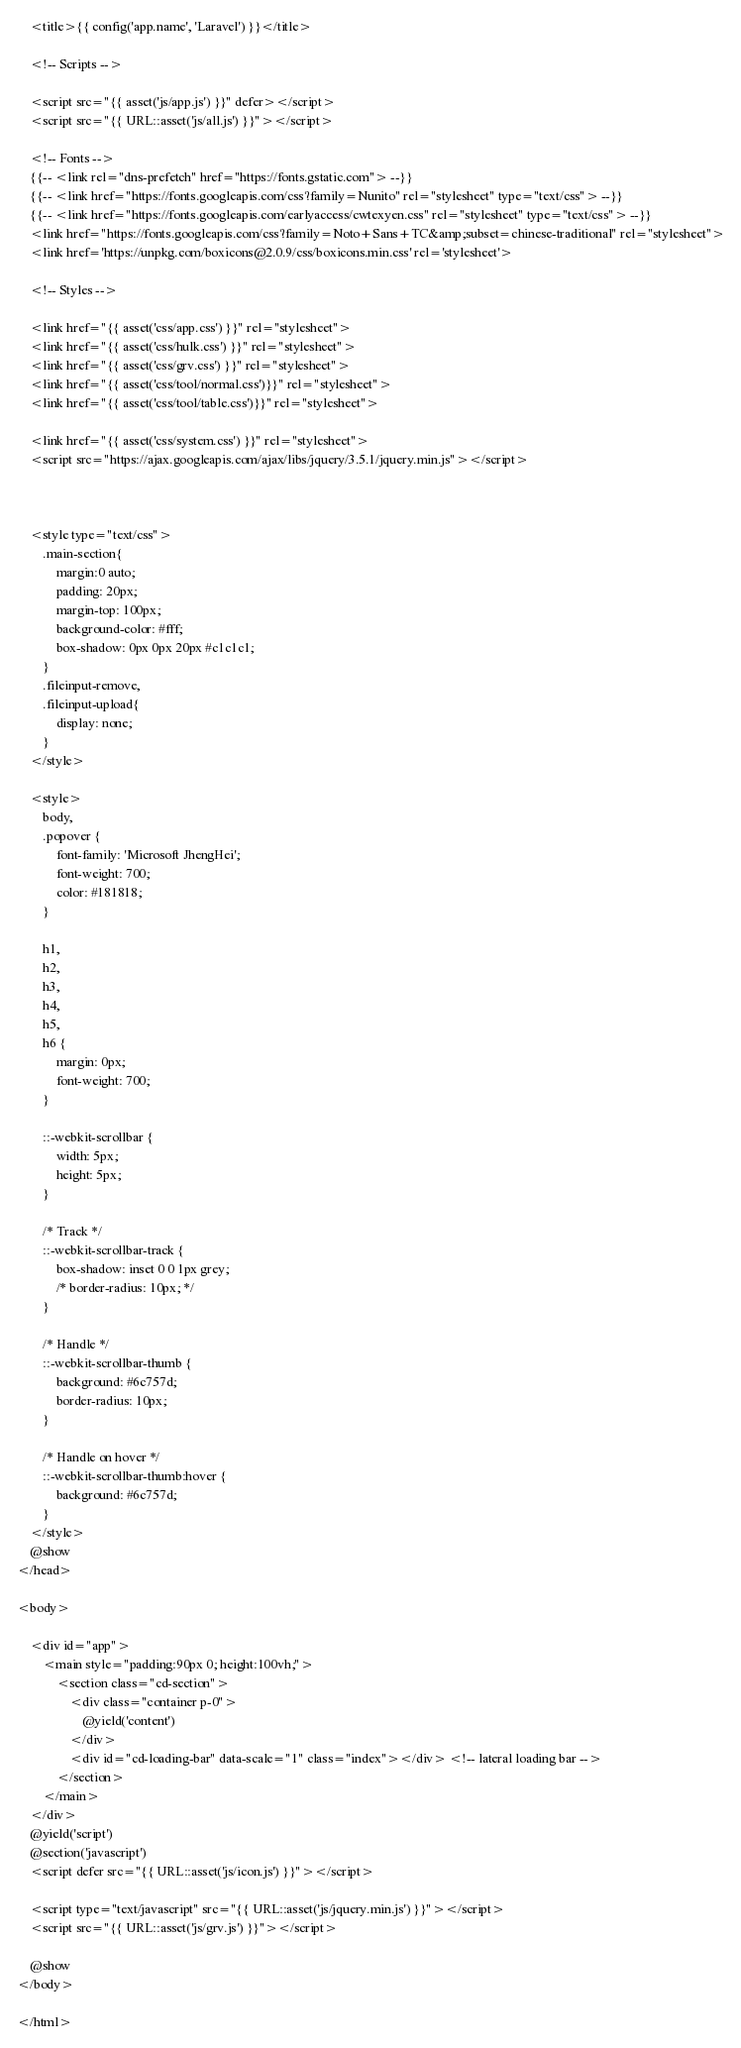Convert code to text. <code><loc_0><loc_0><loc_500><loc_500><_PHP_>
    <title>{{ config('app.name', 'Laravel') }}</title>

    <!-- Scripts -->

    <script src="{{ asset('js/app.js') }}" defer></script>
    <script src="{{ URL::asset('js/all.js') }}"></script>

    <!-- Fonts -->
    {{-- <link rel="dns-prefetch" href="https://fonts.gstatic.com"> --}}
    {{-- <link href="https://fonts.googleapis.com/css?family=Nunito" rel="stylesheet" type="text/css"> --}}
    {{-- <link href="https://fonts.googleapis.com/earlyaccess/cwtexyen.css" rel="stylesheet" type="text/css"> --}}
    <link href="https://fonts.googleapis.com/css?family=Noto+Sans+TC&amp;subset=chinese-traditional" rel="stylesheet">
    <link href='https://unpkg.com/boxicons@2.0.9/css/boxicons.min.css' rel='stylesheet'>

    <!-- Styles -->
    
    <link href="{{ asset('css/app.css') }}" rel="stylesheet">
    <link href="{{ asset('css/hulk.css') }}" rel="stylesheet">
    <link href="{{ asset('css/grv.css') }}" rel="stylesheet">
    <link href="{{ asset('css/tool/normal.css')}}" rel="stylesheet">
    <link href="{{ asset('css/tool/table.css')}}" rel="stylesheet">
    
    <link href="{{ asset('css/system.css') }}" rel="stylesheet">
    <script src="https://ajax.googleapis.com/ajax/libs/jquery/3.5.1/jquery.min.js"></script>



    <style type="text/css">
        .main-section{
            margin:0 auto;
            padding: 20px;
            margin-top: 100px;
            background-color: #fff;
            box-shadow: 0px 0px 20px #c1c1c1;
        }
        .fileinput-remove,
        .fileinput-upload{
            display: none;
        }
    </style>

    <style>
        body,
        .popover {
            font-family: 'Microsoft JhengHei';
            font-weight: 700;
            color: #181818;
        }

        h1,
        h2,
        h3,
        h4,
        h5,
        h6 {
            margin: 0px;
            font-weight: 700;
        }

        ::-webkit-scrollbar {
            width: 5px;
            height: 5px;
        }

        /* Track */
        ::-webkit-scrollbar-track {
            box-shadow: inset 0 0 1px grey;
            /* border-radius: 10px; */
        }

        /* Handle */
        ::-webkit-scrollbar-thumb {
            background: #6c757d;
            border-radius: 10px;
        }

        /* Handle on hover */
        ::-webkit-scrollbar-thumb:hover {
            background: #6c757d;
        }
    </style>
    @show
</head>

<body>
    
    <div id="app">
        <main style="padding:90px 0; height:100vh;">
            <section class="cd-section">
                <div class="container p-0">
                    @yield('content')
                </div>
                <div id="cd-loading-bar" data-scale="1" class="index"></div> <!-- lateral loading bar -->
            </section>
        </main>
    </div>
    @yield('script')
    @section('javascript')
    <script defer src="{{ URL::asset('js/icon.js') }}"></script>

    <script type="text/javascript" src="{{ URL::asset('js/jquery.min.js') }}"></script>
    <script src="{{ URL::asset('js/grv.js') }}"></script>

    @show
</body>

</html></code> 